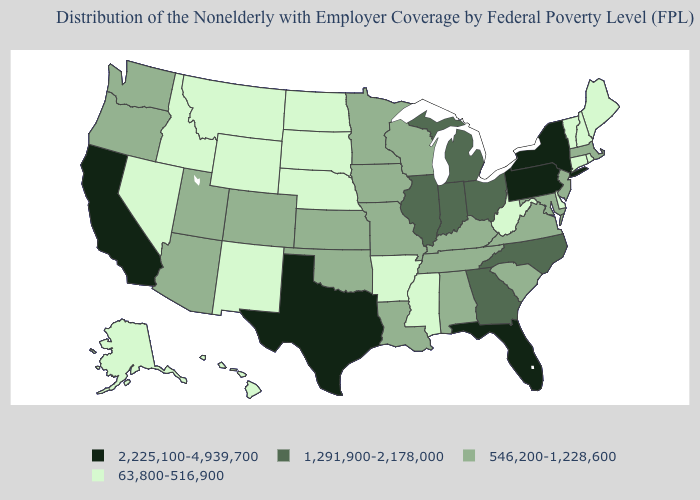Among the states that border Connecticut , which have the lowest value?
Answer briefly. Rhode Island. Name the states that have a value in the range 546,200-1,228,600?
Concise answer only. Alabama, Arizona, Colorado, Iowa, Kansas, Kentucky, Louisiana, Maryland, Massachusetts, Minnesota, Missouri, New Jersey, Oklahoma, Oregon, South Carolina, Tennessee, Utah, Virginia, Washington, Wisconsin. What is the value of Alaska?
Concise answer only. 63,800-516,900. Which states have the highest value in the USA?
Give a very brief answer. California, Florida, New York, Pennsylvania, Texas. Name the states that have a value in the range 1,291,900-2,178,000?
Write a very short answer. Georgia, Illinois, Indiana, Michigan, North Carolina, Ohio. Name the states that have a value in the range 1,291,900-2,178,000?
Quick response, please. Georgia, Illinois, Indiana, Michigan, North Carolina, Ohio. Name the states that have a value in the range 1,291,900-2,178,000?
Concise answer only. Georgia, Illinois, Indiana, Michigan, North Carolina, Ohio. Does West Virginia have a lower value than Oklahoma?
Quick response, please. Yes. Does Georgia have the highest value in the USA?
Short answer required. No. Name the states that have a value in the range 63,800-516,900?
Give a very brief answer. Alaska, Arkansas, Connecticut, Delaware, Hawaii, Idaho, Maine, Mississippi, Montana, Nebraska, Nevada, New Hampshire, New Mexico, North Dakota, Rhode Island, South Dakota, Vermont, West Virginia, Wyoming. Which states hav the highest value in the MidWest?
Quick response, please. Illinois, Indiana, Michigan, Ohio. What is the highest value in the West ?
Answer briefly. 2,225,100-4,939,700. What is the highest value in the USA?
Answer briefly. 2,225,100-4,939,700. 